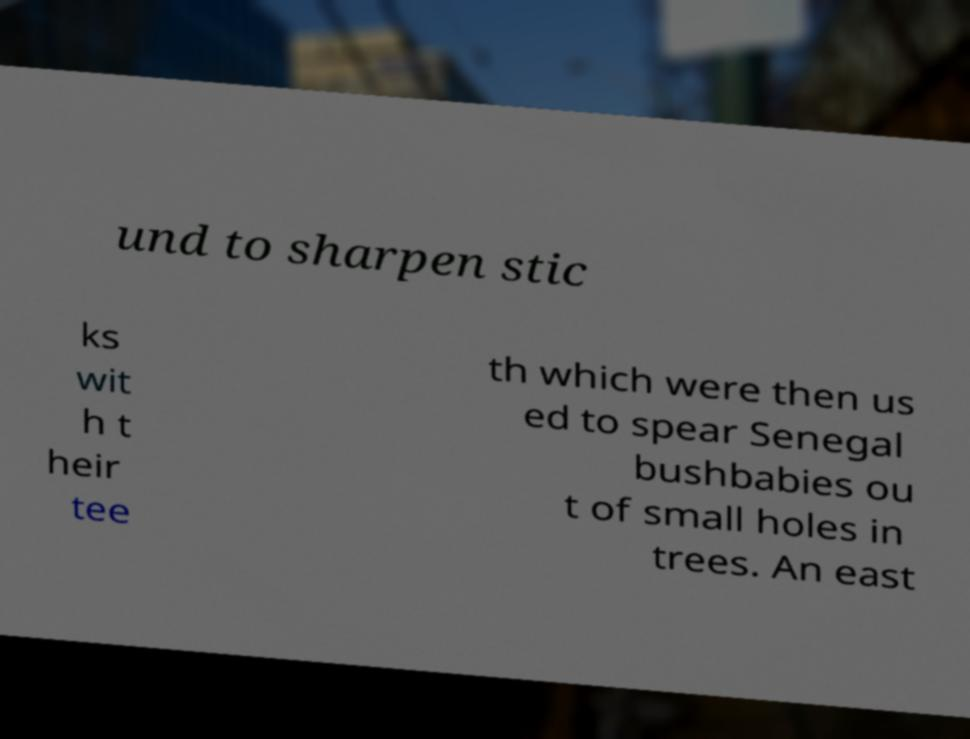I need the written content from this picture converted into text. Can you do that? und to sharpen stic ks wit h t heir tee th which were then us ed to spear Senegal bushbabies ou t of small holes in trees. An east 